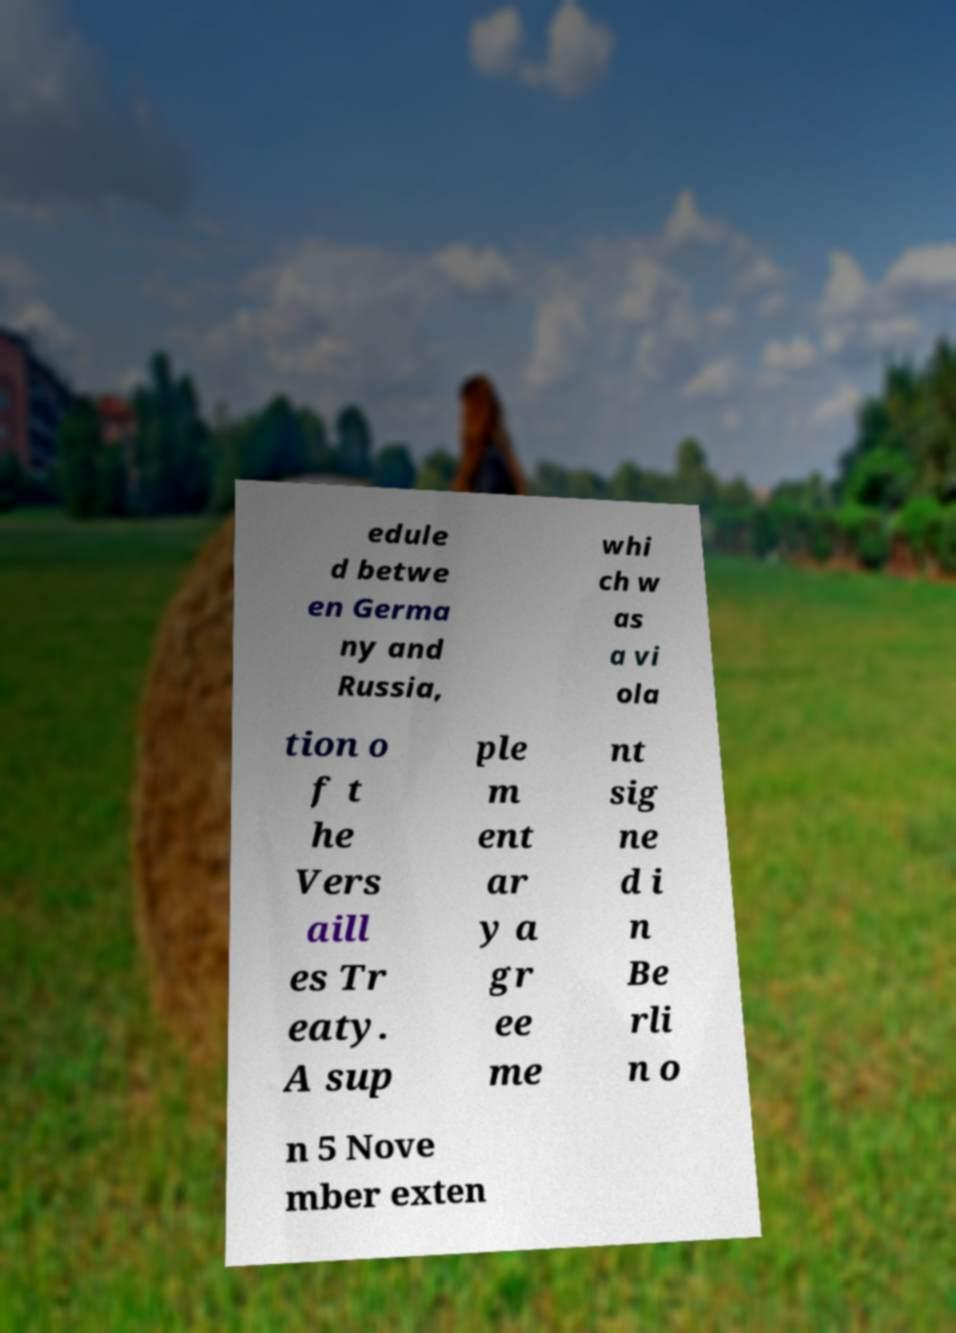For documentation purposes, I need the text within this image transcribed. Could you provide that? edule d betwe en Germa ny and Russia, whi ch w as a vi ola tion o f t he Vers aill es Tr eaty. A sup ple m ent ar y a gr ee me nt sig ne d i n Be rli n o n 5 Nove mber exten 